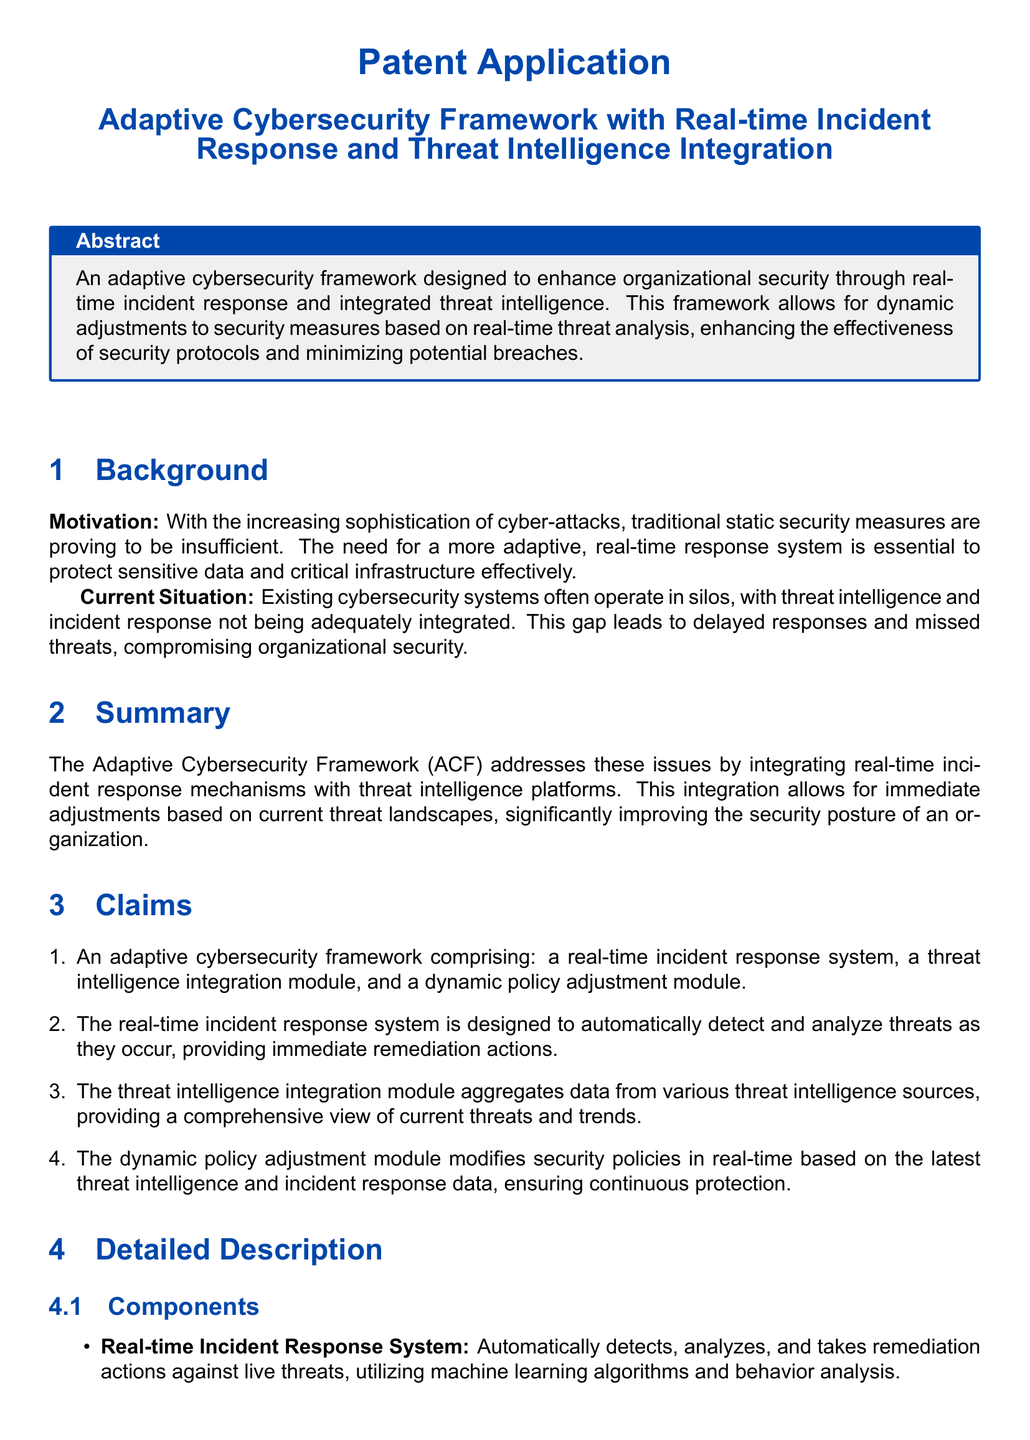what is the title of the patent application? The title is provided in the document header, highlighting the main subject of the invention.
Answer: Adaptive Cybersecurity Framework with Real-time Incident Response and Threat Intelligence Integration what is the main motivation behind the Adaptive Cybersecurity Framework? The motivation is mentioned in the background section, highlighting the need for better security measures.
Answer: Increasing sophistication of cyber-attacks how many main components are listed in the claims? The claims section explicitly states the number of key components in the framework.
Answer: Three which module automatically detects and analyzes threats? The detailed description specifies the function of a particular component of the framework.
Answer: Real-time Incident Response System what is the benefit of the dynamic policy adjustment module? The advantages section explains the functionality and importance of this module in the framework.
Answer: Continuous protection which type of intelligence does the Threat Intelligence Integration Module aggregate? The document details the sources of data that the module collects for a comprehensive view of threats.
Answer: Threat data what feature allows the system to adapt to evolving cyber threats? The workflow section outlines the process that contributes to the system's adaptability.
Answer: Dynamic adjustment of security policies what is one advantage of enhanced threat detection and response? The advantages section identifies outcomes that result from improved response capabilities in the framework.
Answer: More effective responses how does the framework ensure immediate responses to threats? The workflow explains the actions triggered by the detection of threats in the system.
Answer: Continuous monitoring and threat intelligence aggregation 